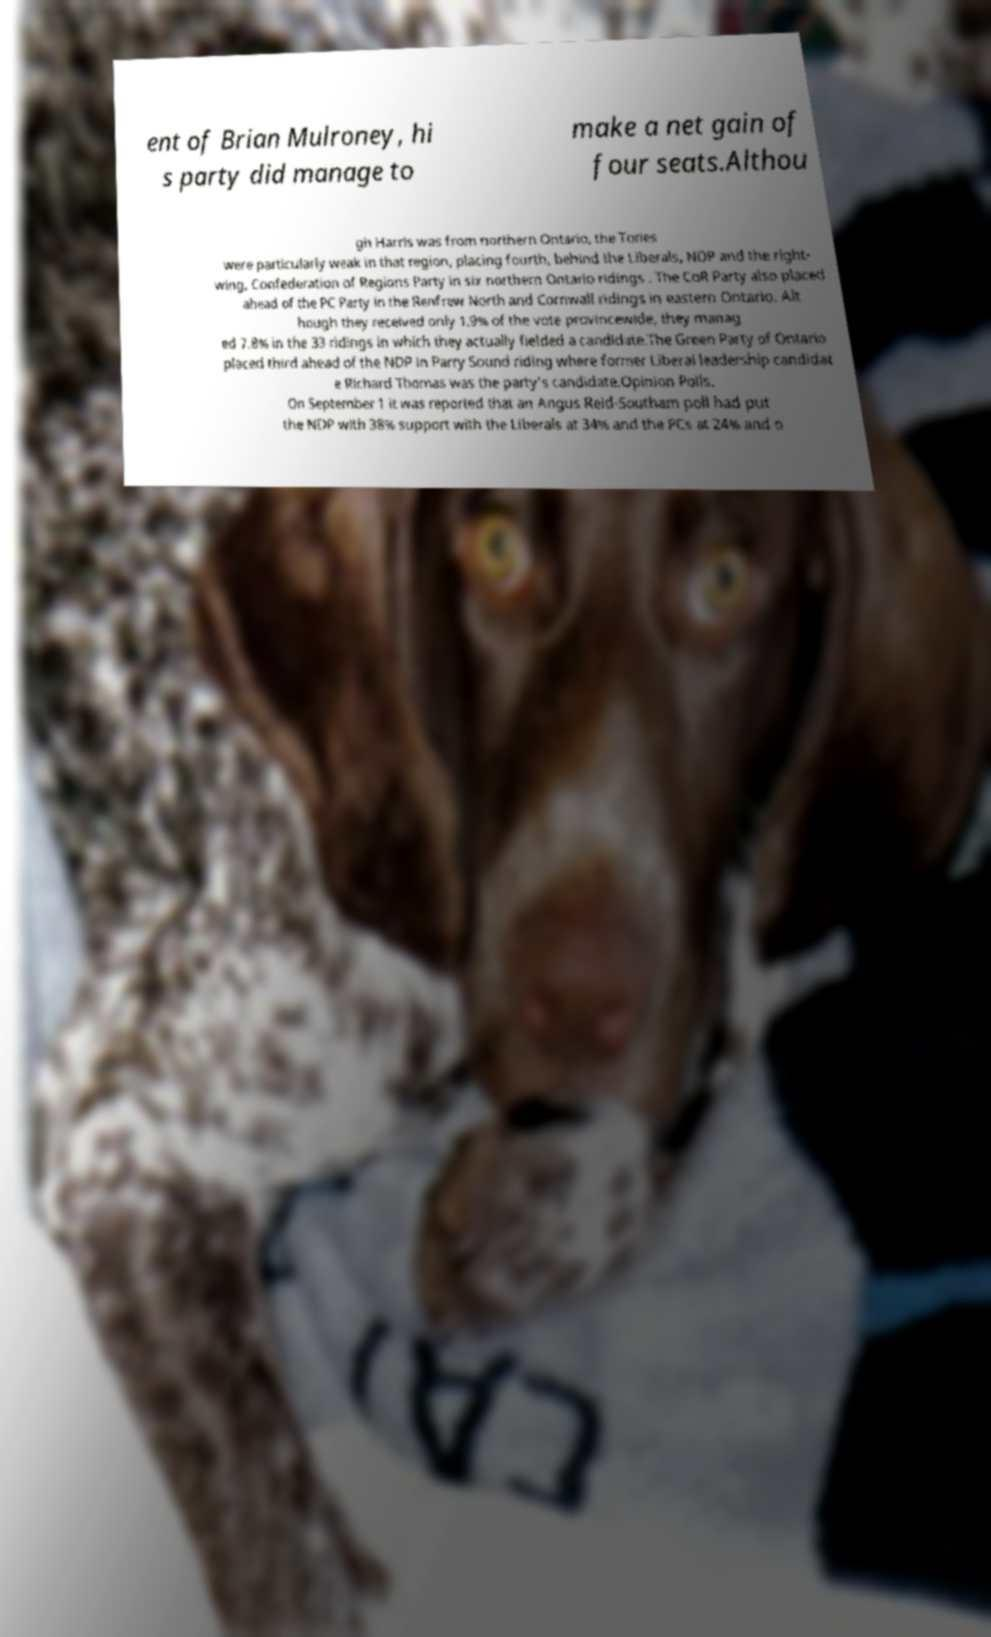Please read and relay the text visible in this image. What does it say? ent of Brian Mulroney, hi s party did manage to make a net gain of four seats.Althou gh Harris was from northern Ontario, the Tories were particularly weak in that region, placing fourth, behind the Liberals, NDP and the right- wing, Confederation of Regions Party in six northern Ontario ridings . The CoR Party also placed ahead of the PC Party in the Renfrew North and Cornwall ridings in eastern Ontario. Alt hough they received only 1.9% of the vote provincewide, they manag ed 7.8% in the 33 ridings in which they actually fielded a candidate.The Green Party of Ontario placed third ahead of the NDP in Parry Sound riding where former Liberal leadership candidat e Richard Thomas was the party's candidate.Opinion Polls. On September 1 it was reported that an Angus Reid-Southam poll had put the NDP with 38% support with the Liberals at 34% and the PCs at 24% and o 